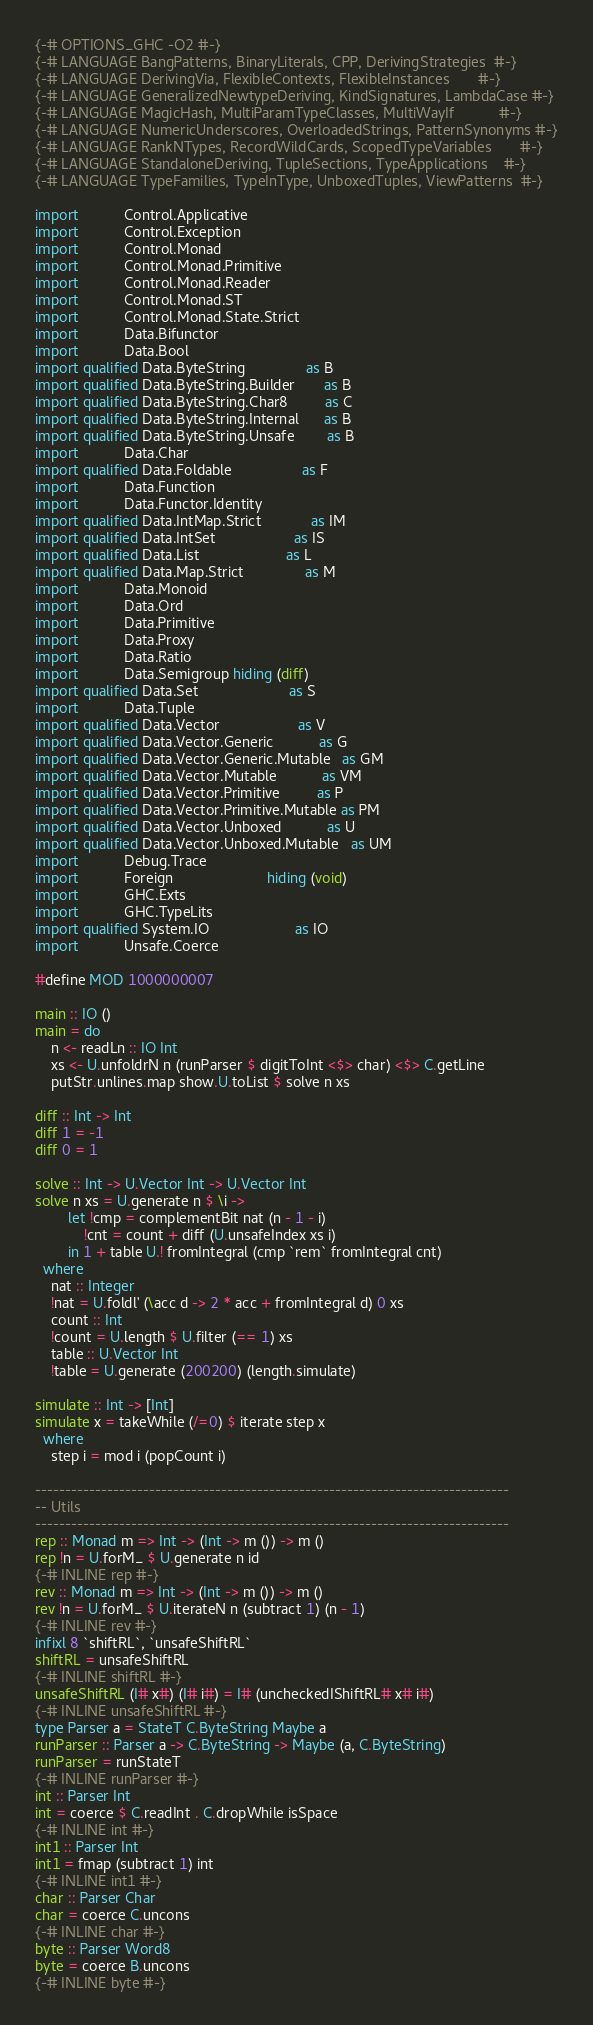<code> <loc_0><loc_0><loc_500><loc_500><_Haskell_>{-# OPTIONS_GHC -O2 #-}
{-# LANGUAGE BangPatterns, BinaryLiterals, CPP, DerivingStrategies  #-}
{-# LANGUAGE DerivingVia, FlexibleContexts, FlexibleInstances       #-}
{-# LANGUAGE GeneralizedNewtypeDeriving, KindSignatures, LambdaCase #-}
{-# LANGUAGE MagicHash, MultiParamTypeClasses, MultiWayIf           #-}
{-# LANGUAGE NumericUnderscores, OverloadedStrings, PatternSynonyms #-}
{-# LANGUAGE RankNTypes, RecordWildCards, ScopedTypeVariables       #-}
{-# LANGUAGE StandaloneDeriving, TupleSections, TypeApplications    #-}
{-# LANGUAGE TypeFamilies, TypeInType, UnboxedTuples, ViewPatterns  #-}

import           Control.Applicative
import           Control.Exception
import           Control.Monad
import           Control.Monad.Primitive
import           Control.Monad.Reader
import           Control.Monad.ST
import           Control.Monad.State.Strict
import           Data.Bifunctor
import           Data.Bool
import qualified Data.ByteString               as B
import qualified Data.ByteString.Builder       as B
import qualified Data.ByteString.Char8         as C
import qualified Data.ByteString.Internal      as B
import qualified Data.ByteString.Unsafe        as B
import           Data.Char
import qualified Data.Foldable                 as F
import           Data.Function
import           Data.Functor.Identity
import qualified Data.IntMap.Strict            as IM
import qualified Data.IntSet                   as IS
import qualified Data.List                     as L
import qualified Data.Map.Strict               as M
import           Data.Monoid
import           Data.Ord
import           Data.Primitive
import           Data.Proxy
import           Data.Ratio
import           Data.Semigroup hiding (diff)
import qualified Data.Set                      as S
import           Data.Tuple
import qualified Data.Vector                   as V
import qualified Data.Vector.Generic           as G
import qualified Data.Vector.Generic.Mutable   as GM
import qualified Data.Vector.Mutable           as VM
import qualified Data.Vector.Primitive         as P
import qualified Data.Vector.Primitive.Mutable as PM
import qualified Data.Vector.Unboxed           as U
import qualified Data.Vector.Unboxed.Mutable   as UM
import           Debug.Trace
import           Foreign                       hiding (void)
import           GHC.Exts
import           GHC.TypeLits
import qualified System.IO                     as IO
import           Unsafe.Coerce

#define MOD 1000000007

main :: IO ()
main = do
    n <- readLn :: IO Int
    xs <- U.unfoldrN n (runParser $ digitToInt <$> char) <$> C.getLine
    putStr.unlines.map show.U.toList $ solve n xs

diff :: Int -> Int
diff 1 = -1
diff 0 = 1

solve :: Int -> U.Vector Int -> U.Vector Int
solve n xs = U.generate n $ \i ->
        let !cmp = complementBit nat (n - 1 - i)
            !cnt = count + diff (U.unsafeIndex xs i)
        in 1 + table U.! fromIntegral (cmp `rem` fromIntegral cnt)
  where
    nat :: Integer
    !nat = U.foldl' (\acc d -> 2 * acc + fromIntegral d) 0 xs
    count :: Int
    !count = U.length $ U.filter (== 1) xs
    table :: U.Vector Int
    !table = U.generate (200200) (length.simulate)

simulate :: Int -> [Int]
simulate x = takeWhile (/=0) $ iterate step x
  where
    step i = mod i (popCount i)

-------------------------------------------------------------------------------
-- Utils
-------------------------------------------------------------------------------
rep :: Monad m => Int -> (Int -> m ()) -> m ()
rep !n = U.forM_ $ U.generate n id
{-# INLINE rep #-}
rev :: Monad m => Int -> (Int -> m ()) -> m ()
rev !n = U.forM_ $ U.iterateN n (subtract 1) (n - 1)
{-# INLINE rev #-}
infixl 8 `shiftRL`, `unsafeShiftRL`
shiftRL = unsafeShiftRL
{-# INLINE shiftRL #-}
unsafeShiftRL (I# x#) (I# i#) = I# (uncheckedIShiftRL# x# i#)
{-# INLINE unsafeShiftRL #-}
type Parser a = StateT C.ByteString Maybe a
runParser :: Parser a -> C.ByteString -> Maybe (a, C.ByteString)
runParser = runStateT
{-# INLINE runParser #-}
int :: Parser Int
int = coerce $ C.readInt . C.dropWhile isSpace
{-# INLINE int #-}
int1 :: Parser Int
int1 = fmap (subtract 1) int
{-# INLINE int1 #-}
char :: Parser Char
char = coerce C.uncons
{-# INLINE char #-}
byte :: Parser Word8
byte = coerce B.uncons
{-# INLINE byte #-}
</code> 